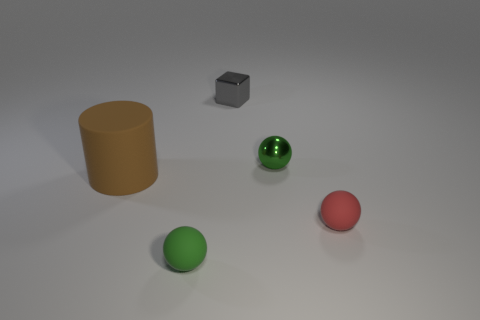Subtract all matte spheres. How many spheres are left? 1 Add 3 big brown cylinders. How many objects exist? 8 Subtract all balls. How many objects are left? 2 Subtract all small gray blocks. Subtract all large red matte cubes. How many objects are left? 4 Add 4 objects. How many objects are left? 9 Add 4 large red cylinders. How many large red cylinders exist? 4 Subtract 0 purple blocks. How many objects are left? 5 